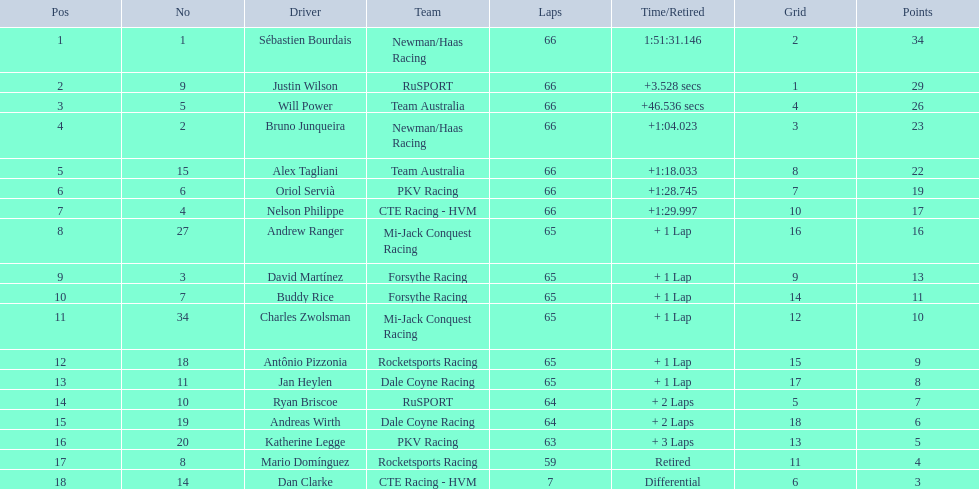Which drivers reached 10 points or more? Sébastien Bourdais, Justin Wilson, Will Power, Bruno Junqueira, Alex Tagliani, Oriol Servià, Nelson Philippe, Andrew Ranger, David Martínez, Buddy Rice, Charles Zwolsman. Of those drivers, which ones managed to score 20 points or more? Sébastien Bourdais, Justin Wilson, Will Power, Bruno Junqueira, Alex Tagliani. Of those 5, which driver secured the greatest number of points? Sébastien Bourdais. Would you be able to parse every entry in this table? {'header': ['Pos', 'No', 'Driver', 'Team', 'Laps', 'Time/Retired', 'Grid', 'Points'], 'rows': [['1', '1', 'Sébastien Bourdais', 'Newman/Haas Racing', '66', '1:51:31.146', '2', '34'], ['2', '9', 'Justin Wilson', 'RuSPORT', '66', '+3.528 secs', '1', '29'], ['3', '5', 'Will Power', 'Team Australia', '66', '+46.536 secs', '4', '26'], ['4', '2', 'Bruno Junqueira', 'Newman/Haas Racing', '66', '+1:04.023', '3', '23'], ['5', '15', 'Alex Tagliani', 'Team Australia', '66', '+1:18.033', '8', '22'], ['6', '6', 'Oriol Servià', 'PKV Racing', '66', '+1:28.745', '7', '19'], ['7', '4', 'Nelson Philippe', 'CTE Racing - HVM', '66', '+1:29.997', '10', '17'], ['8', '27', 'Andrew Ranger', 'Mi-Jack Conquest Racing', '65', '+ 1 Lap', '16', '16'], ['9', '3', 'David Martínez', 'Forsythe Racing', '65', '+ 1 Lap', '9', '13'], ['10', '7', 'Buddy Rice', 'Forsythe Racing', '65', '+ 1 Lap', '14', '11'], ['11', '34', 'Charles Zwolsman', 'Mi-Jack Conquest Racing', '65', '+ 1 Lap', '12', '10'], ['12', '18', 'Antônio Pizzonia', 'Rocketsports Racing', '65', '+ 1 Lap', '15', '9'], ['13', '11', 'Jan Heylen', 'Dale Coyne Racing', '65', '+ 1 Lap', '17', '8'], ['14', '10', 'Ryan Briscoe', 'RuSPORT', '64', '+ 2 Laps', '5', '7'], ['15', '19', 'Andreas Wirth', 'Dale Coyne Racing', '64', '+ 2 Laps', '18', '6'], ['16', '20', 'Katherine Legge', 'PKV Racing', '63', '+ 3 Laps', '13', '5'], ['17', '8', 'Mario Domínguez', 'Rocketsports Racing', '59', 'Retired', '11', '4'], ['18', '14', 'Dan Clarke', 'CTE Racing - HVM', '7', 'Differential', '6', '3']]} 